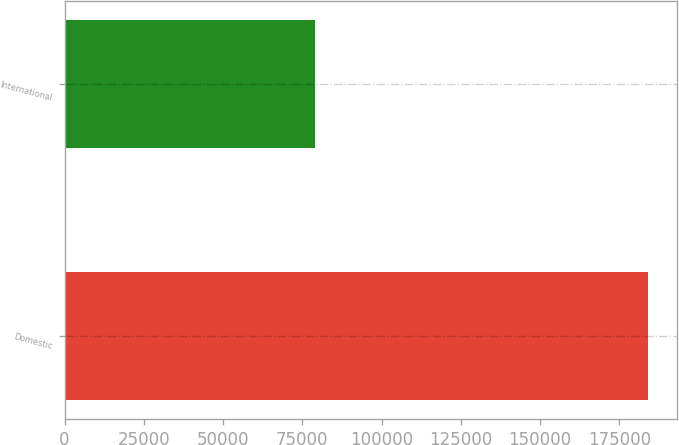<chart> <loc_0><loc_0><loc_500><loc_500><bar_chart><fcel>Domestic<fcel>International<nl><fcel>184086<fcel>79175<nl></chart> 